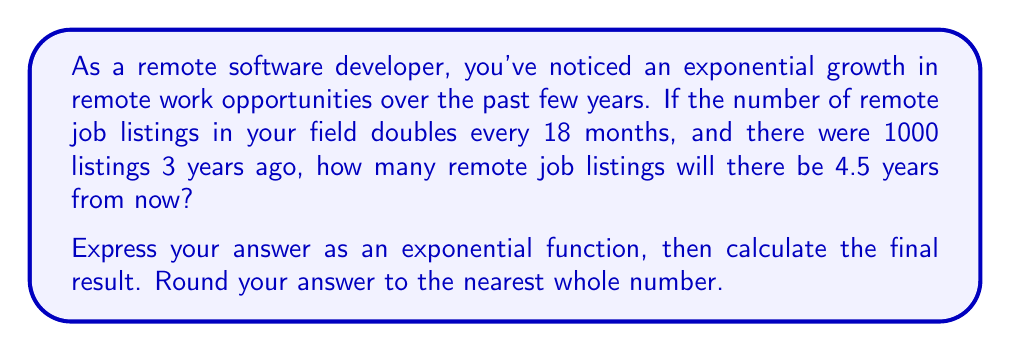Teach me how to tackle this problem. Let's approach this step-by-step:

1) First, we need to set up our exponential function. The general form is:

   $$ A(t) = A_0 \cdot b^t $$

   Where $A_0$ is the initial amount, $b$ is the growth factor, and $t$ is the time.

2) We know:
   - Initial amount ($A_0$) = 1000 listings
   - The number doubles every 18 months, so $b = 2^{\frac{1}{1.5}} = 2^{\frac{2}{3}}$
   - We want to know the amount after 7.5 years (3 years ago + 4.5 years from now)

3) We need to express time in terms of 18-month periods:
   $$ t = \frac{7.5 \text{ years}}{1.5 \text{ years}} = 5 \text{ periods} $$

4) Now we can set up our function:

   $$ A(5) = 1000 \cdot (2^{\frac{2}{3}})^5 $$

5) Simplify the exponent:

   $$ A(5) = 1000 \cdot 2^{\frac{10}{3}} $$

6) Calculate:

   $$ A(5) = 1000 \cdot 2^{3.333...} $$
   $$ A(5) = 1000 \cdot 10.0793... $$
   $$ A(5) = 10079.3... $$

7) Rounding to the nearest whole number:

   $$ A(5) \approx 10079 $$
Answer: The exponential function is $A(t) = 1000 \cdot (2^{\frac{2}{3}})^t$, where $t$ is the number of 18-month periods.

The number of remote job listings 4.5 years from now will be approximately 10,079. 